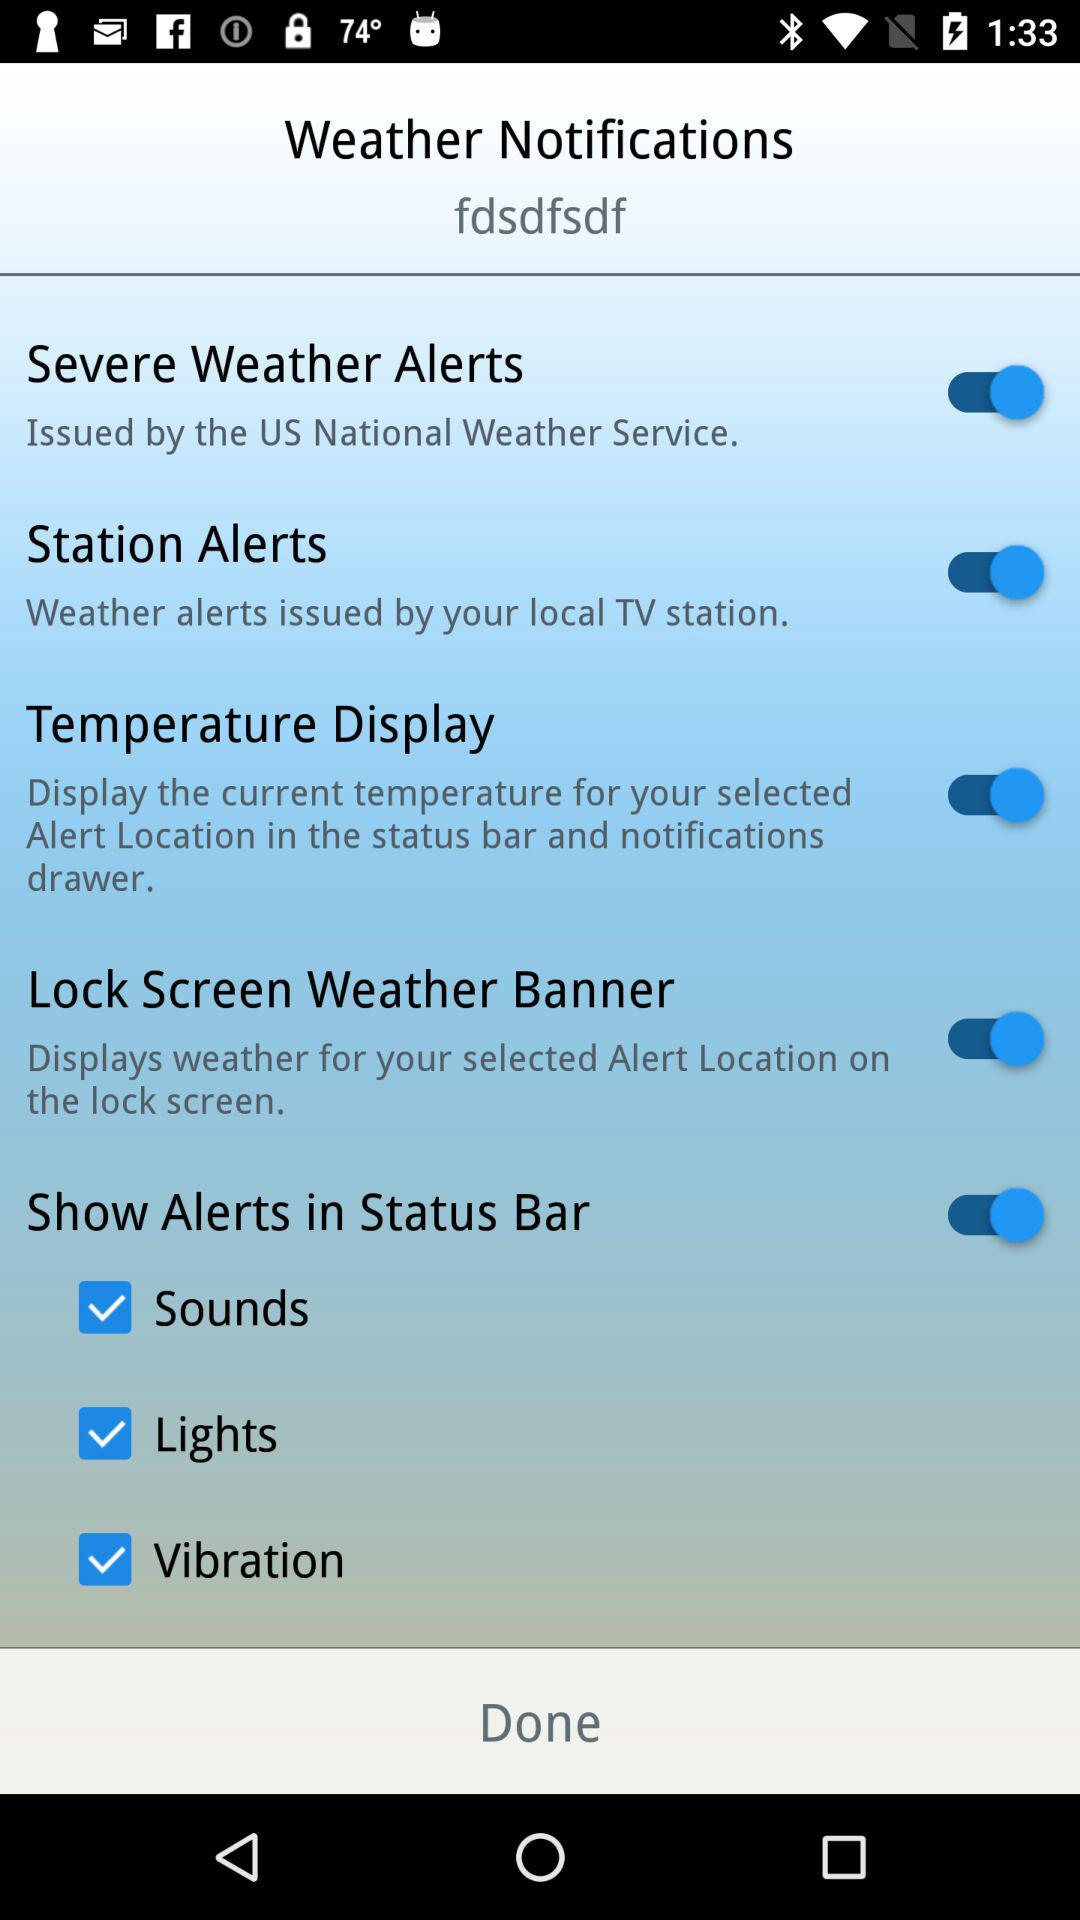What is the current status of "Sounds"? The status is on. 